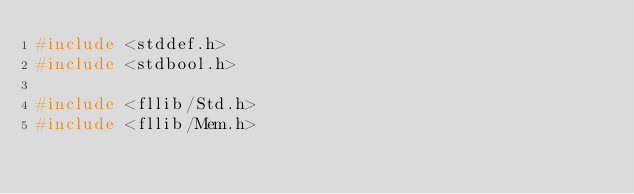<code> <loc_0><loc_0><loc_500><loc_500><_C_>#include <stddef.h>
#include <stdbool.h>

#include <fllib/Std.h>
#include <fllib/Mem.h></code> 